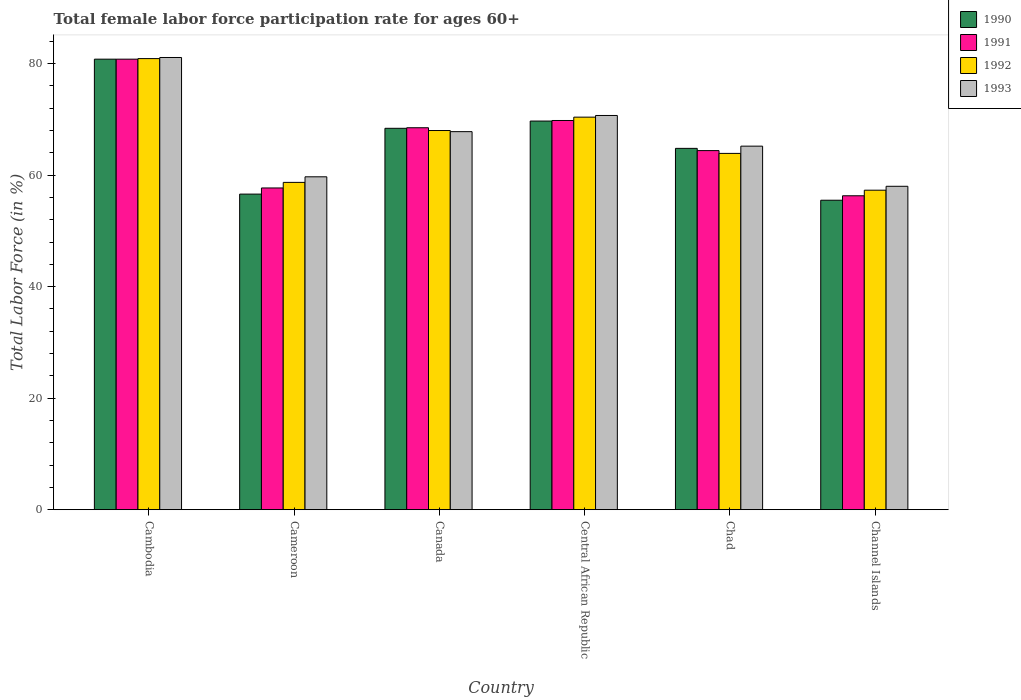How many different coloured bars are there?
Keep it short and to the point. 4. Are the number of bars per tick equal to the number of legend labels?
Keep it short and to the point. Yes. Are the number of bars on each tick of the X-axis equal?
Provide a succinct answer. Yes. How many bars are there on the 5th tick from the right?
Your answer should be compact. 4. In how many cases, is the number of bars for a given country not equal to the number of legend labels?
Give a very brief answer. 0. What is the female labor force participation rate in 1992 in Channel Islands?
Ensure brevity in your answer.  57.3. Across all countries, what is the maximum female labor force participation rate in 1993?
Your response must be concise. 81.1. Across all countries, what is the minimum female labor force participation rate in 1991?
Your answer should be very brief. 56.3. In which country was the female labor force participation rate in 1993 maximum?
Give a very brief answer. Cambodia. In which country was the female labor force participation rate in 1990 minimum?
Your response must be concise. Channel Islands. What is the total female labor force participation rate in 1993 in the graph?
Your answer should be very brief. 402.5. What is the difference between the female labor force participation rate in 1990 in Cambodia and that in Canada?
Provide a short and direct response. 12.4. What is the difference between the female labor force participation rate in 1990 in Channel Islands and the female labor force participation rate in 1992 in Cameroon?
Your response must be concise. -3.2. What is the average female labor force participation rate in 1990 per country?
Your answer should be very brief. 65.97. What is the difference between the female labor force participation rate of/in 1992 and female labor force participation rate of/in 1993 in Chad?
Your answer should be very brief. -1.3. In how many countries, is the female labor force participation rate in 1992 greater than 56 %?
Your response must be concise. 6. What is the ratio of the female labor force participation rate in 1993 in Cambodia to that in Central African Republic?
Keep it short and to the point. 1.15. Is the female labor force participation rate in 1990 in Central African Republic less than that in Chad?
Ensure brevity in your answer.  No. What is the difference between the highest and the second highest female labor force participation rate in 1990?
Make the answer very short. 12.4. What is the difference between the highest and the lowest female labor force participation rate in 1991?
Your response must be concise. 24.5. In how many countries, is the female labor force participation rate in 1990 greater than the average female labor force participation rate in 1990 taken over all countries?
Give a very brief answer. 3. Is the sum of the female labor force participation rate in 1991 in Central African Republic and Channel Islands greater than the maximum female labor force participation rate in 1992 across all countries?
Give a very brief answer. Yes. Is it the case that in every country, the sum of the female labor force participation rate in 1990 and female labor force participation rate in 1992 is greater than the sum of female labor force participation rate in 1993 and female labor force participation rate in 1991?
Ensure brevity in your answer.  No. What does the 3rd bar from the left in Canada represents?
Offer a terse response. 1992. How many bars are there?
Provide a short and direct response. 24. Are all the bars in the graph horizontal?
Your response must be concise. No. What is the difference between two consecutive major ticks on the Y-axis?
Offer a terse response. 20. Does the graph contain any zero values?
Give a very brief answer. No. Where does the legend appear in the graph?
Provide a succinct answer. Top right. What is the title of the graph?
Offer a terse response. Total female labor force participation rate for ages 60+. Does "2003" appear as one of the legend labels in the graph?
Your answer should be very brief. No. What is the label or title of the X-axis?
Keep it short and to the point. Country. What is the Total Labor Force (in %) of 1990 in Cambodia?
Ensure brevity in your answer.  80.8. What is the Total Labor Force (in %) of 1991 in Cambodia?
Keep it short and to the point. 80.8. What is the Total Labor Force (in %) in 1992 in Cambodia?
Make the answer very short. 80.9. What is the Total Labor Force (in %) in 1993 in Cambodia?
Offer a terse response. 81.1. What is the Total Labor Force (in %) in 1990 in Cameroon?
Make the answer very short. 56.6. What is the Total Labor Force (in %) in 1991 in Cameroon?
Offer a terse response. 57.7. What is the Total Labor Force (in %) of 1992 in Cameroon?
Provide a succinct answer. 58.7. What is the Total Labor Force (in %) in 1993 in Cameroon?
Make the answer very short. 59.7. What is the Total Labor Force (in %) in 1990 in Canada?
Your response must be concise. 68.4. What is the Total Labor Force (in %) in 1991 in Canada?
Provide a short and direct response. 68.5. What is the Total Labor Force (in %) of 1992 in Canada?
Keep it short and to the point. 68. What is the Total Labor Force (in %) in 1993 in Canada?
Your answer should be compact. 67.8. What is the Total Labor Force (in %) in 1990 in Central African Republic?
Provide a succinct answer. 69.7. What is the Total Labor Force (in %) in 1991 in Central African Republic?
Give a very brief answer. 69.8. What is the Total Labor Force (in %) of 1992 in Central African Republic?
Provide a short and direct response. 70.4. What is the Total Labor Force (in %) in 1993 in Central African Republic?
Keep it short and to the point. 70.7. What is the Total Labor Force (in %) in 1990 in Chad?
Your answer should be very brief. 64.8. What is the Total Labor Force (in %) of 1991 in Chad?
Provide a succinct answer. 64.4. What is the Total Labor Force (in %) of 1992 in Chad?
Keep it short and to the point. 63.9. What is the Total Labor Force (in %) in 1993 in Chad?
Make the answer very short. 65.2. What is the Total Labor Force (in %) of 1990 in Channel Islands?
Your response must be concise. 55.5. What is the Total Labor Force (in %) of 1991 in Channel Islands?
Offer a terse response. 56.3. What is the Total Labor Force (in %) of 1992 in Channel Islands?
Provide a short and direct response. 57.3. What is the Total Labor Force (in %) in 1993 in Channel Islands?
Give a very brief answer. 58. Across all countries, what is the maximum Total Labor Force (in %) in 1990?
Give a very brief answer. 80.8. Across all countries, what is the maximum Total Labor Force (in %) in 1991?
Offer a very short reply. 80.8. Across all countries, what is the maximum Total Labor Force (in %) of 1992?
Ensure brevity in your answer.  80.9. Across all countries, what is the maximum Total Labor Force (in %) in 1993?
Your answer should be very brief. 81.1. Across all countries, what is the minimum Total Labor Force (in %) in 1990?
Provide a short and direct response. 55.5. Across all countries, what is the minimum Total Labor Force (in %) in 1991?
Make the answer very short. 56.3. Across all countries, what is the minimum Total Labor Force (in %) in 1992?
Your response must be concise. 57.3. Across all countries, what is the minimum Total Labor Force (in %) of 1993?
Your answer should be very brief. 58. What is the total Total Labor Force (in %) of 1990 in the graph?
Offer a terse response. 395.8. What is the total Total Labor Force (in %) in 1991 in the graph?
Provide a short and direct response. 397.5. What is the total Total Labor Force (in %) of 1992 in the graph?
Provide a succinct answer. 399.2. What is the total Total Labor Force (in %) in 1993 in the graph?
Your answer should be compact. 402.5. What is the difference between the Total Labor Force (in %) in 1990 in Cambodia and that in Cameroon?
Offer a very short reply. 24.2. What is the difference between the Total Labor Force (in %) in 1991 in Cambodia and that in Cameroon?
Your response must be concise. 23.1. What is the difference between the Total Labor Force (in %) of 1992 in Cambodia and that in Cameroon?
Your response must be concise. 22.2. What is the difference between the Total Labor Force (in %) in 1993 in Cambodia and that in Cameroon?
Your answer should be very brief. 21.4. What is the difference between the Total Labor Force (in %) in 1990 in Cambodia and that in Canada?
Make the answer very short. 12.4. What is the difference between the Total Labor Force (in %) of 1991 in Cambodia and that in Canada?
Ensure brevity in your answer.  12.3. What is the difference between the Total Labor Force (in %) of 1992 in Cambodia and that in Canada?
Keep it short and to the point. 12.9. What is the difference between the Total Labor Force (in %) of 1990 in Cambodia and that in Central African Republic?
Offer a terse response. 11.1. What is the difference between the Total Labor Force (in %) in 1992 in Cambodia and that in Central African Republic?
Provide a succinct answer. 10.5. What is the difference between the Total Labor Force (in %) in 1990 in Cambodia and that in Chad?
Offer a terse response. 16. What is the difference between the Total Labor Force (in %) in 1991 in Cambodia and that in Chad?
Ensure brevity in your answer.  16.4. What is the difference between the Total Labor Force (in %) in 1993 in Cambodia and that in Chad?
Offer a terse response. 15.9. What is the difference between the Total Labor Force (in %) of 1990 in Cambodia and that in Channel Islands?
Give a very brief answer. 25.3. What is the difference between the Total Labor Force (in %) of 1992 in Cambodia and that in Channel Islands?
Your answer should be very brief. 23.6. What is the difference between the Total Labor Force (in %) of 1993 in Cambodia and that in Channel Islands?
Provide a short and direct response. 23.1. What is the difference between the Total Labor Force (in %) in 1991 in Cameroon and that in Canada?
Offer a terse response. -10.8. What is the difference between the Total Labor Force (in %) in 1992 in Cameroon and that in Canada?
Offer a terse response. -9.3. What is the difference between the Total Labor Force (in %) of 1993 in Cameroon and that in Canada?
Your answer should be very brief. -8.1. What is the difference between the Total Labor Force (in %) of 1990 in Cameroon and that in Central African Republic?
Offer a very short reply. -13.1. What is the difference between the Total Labor Force (in %) in 1992 in Cameroon and that in Central African Republic?
Your response must be concise. -11.7. What is the difference between the Total Labor Force (in %) of 1990 in Cameroon and that in Chad?
Keep it short and to the point. -8.2. What is the difference between the Total Labor Force (in %) of 1993 in Cameroon and that in Chad?
Offer a terse response. -5.5. What is the difference between the Total Labor Force (in %) of 1990 in Cameroon and that in Channel Islands?
Make the answer very short. 1.1. What is the difference between the Total Labor Force (in %) in 1992 in Cameroon and that in Channel Islands?
Keep it short and to the point. 1.4. What is the difference between the Total Labor Force (in %) of 1993 in Cameroon and that in Channel Islands?
Provide a succinct answer. 1.7. What is the difference between the Total Labor Force (in %) of 1990 in Canada and that in Central African Republic?
Give a very brief answer. -1.3. What is the difference between the Total Labor Force (in %) of 1992 in Canada and that in Central African Republic?
Your answer should be compact. -2.4. What is the difference between the Total Labor Force (in %) in 1990 in Canada and that in Chad?
Give a very brief answer. 3.6. What is the difference between the Total Labor Force (in %) in 1992 in Canada and that in Chad?
Offer a very short reply. 4.1. What is the difference between the Total Labor Force (in %) in 1993 in Canada and that in Chad?
Ensure brevity in your answer.  2.6. What is the difference between the Total Labor Force (in %) of 1990 in Central African Republic and that in Chad?
Keep it short and to the point. 4.9. What is the difference between the Total Labor Force (in %) of 1991 in Central African Republic and that in Chad?
Offer a very short reply. 5.4. What is the difference between the Total Labor Force (in %) in 1992 in Central African Republic and that in Chad?
Provide a succinct answer. 6.5. What is the difference between the Total Labor Force (in %) of 1990 in Central African Republic and that in Channel Islands?
Provide a succinct answer. 14.2. What is the difference between the Total Labor Force (in %) of 1991 in Central African Republic and that in Channel Islands?
Provide a short and direct response. 13.5. What is the difference between the Total Labor Force (in %) of 1992 in Central African Republic and that in Channel Islands?
Your answer should be compact. 13.1. What is the difference between the Total Labor Force (in %) in 1993 in Central African Republic and that in Channel Islands?
Keep it short and to the point. 12.7. What is the difference between the Total Labor Force (in %) of 1992 in Chad and that in Channel Islands?
Keep it short and to the point. 6.6. What is the difference between the Total Labor Force (in %) of 1993 in Chad and that in Channel Islands?
Offer a terse response. 7.2. What is the difference between the Total Labor Force (in %) of 1990 in Cambodia and the Total Labor Force (in %) of 1991 in Cameroon?
Offer a very short reply. 23.1. What is the difference between the Total Labor Force (in %) of 1990 in Cambodia and the Total Labor Force (in %) of 1992 in Cameroon?
Give a very brief answer. 22.1. What is the difference between the Total Labor Force (in %) in 1990 in Cambodia and the Total Labor Force (in %) in 1993 in Cameroon?
Keep it short and to the point. 21.1. What is the difference between the Total Labor Force (in %) in 1991 in Cambodia and the Total Labor Force (in %) in 1992 in Cameroon?
Your answer should be very brief. 22.1. What is the difference between the Total Labor Force (in %) in 1991 in Cambodia and the Total Labor Force (in %) in 1993 in Cameroon?
Offer a very short reply. 21.1. What is the difference between the Total Labor Force (in %) in 1992 in Cambodia and the Total Labor Force (in %) in 1993 in Cameroon?
Provide a succinct answer. 21.2. What is the difference between the Total Labor Force (in %) of 1990 in Cambodia and the Total Labor Force (in %) of 1991 in Canada?
Your answer should be compact. 12.3. What is the difference between the Total Labor Force (in %) of 1990 in Cambodia and the Total Labor Force (in %) of 1992 in Canada?
Your response must be concise. 12.8. What is the difference between the Total Labor Force (in %) of 1991 in Cambodia and the Total Labor Force (in %) of 1992 in Canada?
Give a very brief answer. 12.8. What is the difference between the Total Labor Force (in %) of 1991 in Cambodia and the Total Labor Force (in %) of 1993 in Canada?
Provide a succinct answer. 13. What is the difference between the Total Labor Force (in %) of 1990 in Cambodia and the Total Labor Force (in %) of 1991 in Central African Republic?
Give a very brief answer. 11. What is the difference between the Total Labor Force (in %) of 1990 in Cambodia and the Total Labor Force (in %) of 1993 in Central African Republic?
Your answer should be compact. 10.1. What is the difference between the Total Labor Force (in %) of 1991 in Cambodia and the Total Labor Force (in %) of 1993 in Central African Republic?
Make the answer very short. 10.1. What is the difference between the Total Labor Force (in %) of 1990 in Cambodia and the Total Labor Force (in %) of 1991 in Chad?
Offer a terse response. 16.4. What is the difference between the Total Labor Force (in %) in 1990 in Cambodia and the Total Labor Force (in %) in 1992 in Chad?
Offer a terse response. 16.9. What is the difference between the Total Labor Force (in %) in 1990 in Cambodia and the Total Labor Force (in %) in 1991 in Channel Islands?
Ensure brevity in your answer.  24.5. What is the difference between the Total Labor Force (in %) of 1990 in Cambodia and the Total Labor Force (in %) of 1992 in Channel Islands?
Your answer should be compact. 23.5. What is the difference between the Total Labor Force (in %) in 1990 in Cambodia and the Total Labor Force (in %) in 1993 in Channel Islands?
Your answer should be compact. 22.8. What is the difference between the Total Labor Force (in %) in 1991 in Cambodia and the Total Labor Force (in %) in 1992 in Channel Islands?
Offer a terse response. 23.5. What is the difference between the Total Labor Force (in %) of 1991 in Cambodia and the Total Labor Force (in %) of 1993 in Channel Islands?
Offer a very short reply. 22.8. What is the difference between the Total Labor Force (in %) of 1992 in Cambodia and the Total Labor Force (in %) of 1993 in Channel Islands?
Ensure brevity in your answer.  22.9. What is the difference between the Total Labor Force (in %) of 1990 in Cameroon and the Total Labor Force (in %) of 1992 in Canada?
Provide a succinct answer. -11.4. What is the difference between the Total Labor Force (in %) in 1990 in Cameroon and the Total Labor Force (in %) in 1993 in Canada?
Your answer should be very brief. -11.2. What is the difference between the Total Labor Force (in %) of 1992 in Cameroon and the Total Labor Force (in %) of 1993 in Canada?
Provide a short and direct response. -9.1. What is the difference between the Total Labor Force (in %) in 1990 in Cameroon and the Total Labor Force (in %) in 1993 in Central African Republic?
Your answer should be compact. -14.1. What is the difference between the Total Labor Force (in %) of 1991 in Cameroon and the Total Labor Force (in %) of 1992 in Central African Republic?
Provide a short and direct response. -12.7. What is the difference between the Total Labor Force (in %) of 1991 in Cameroon and the Total Labor Force (in %) of 1993 in Central African Republic?
Provide a succinct answer. -13. What is the difference between the Total Labor Force (in %) of 1992 in Cameroon and the Total Labor Force (in %) of 1993 in Central African Republic?
Make the answer very short. -12. What is the difference between the Total Labor Force (in %) of 1990 in Cameroon and the Total Labor Force (in %) of 1991 in Chad?
Keep it short and to the point. -7.8. What is the difference between the Total Labor Force (in %) of 1990 in Cameroon and the Total Labor Force (in %) of 1991 in Channel Islands?
Offer a terse response. 0.3. What is the difference between the Total Labor Force (in %) in 1990 in Cameroon and the Total Labor Force (in %) in 1992 in Channel Islands?
Offer a terse response. -0.7. What is the difference between the Total Labor Force (in %) of 1990 in Cameroon and the Total Labor Force (in %) of 1993 in Channel Islands?
Keep it short and to the point. -1.4. What is the difference between the Total Labor Force (in %) in 1991 in Cameroon and the Total Labor Force (in %) in 1992 in Channel Islands?
Offer a very short reply. 0.4. What is the difference between the Total Labor Force (in %) in 1991 in Cameroon and the Total Labor Force (in %) in 1993 in Channel Islands?
Your answer should be very brief. -0.3. What is the difference between the Total Labor Force (in %) of 1990 in Canada and the Total Labor Force (in %) of 1991 in Central African Republic?
Your answer should be very brief. -1.4. What is the difference between the Total Labor Force (in %) in 1990 in Canada and the Total Labor Force (in %) in 1992 in Central African Republic?
Your answer should be very brief. -2. What is the difference between the Total Labor Force (in %) of 1990 in Canada and the Total Labor Force (in %) of 1993 in Central African Republic?
Your answer should be compact. -2.3. What is the difference between the Total Labor Force (in %) of 1991 in Canada and the Total Labor Force (in %) of 1992 in Central African Republic?
Give a very brief answer. -1.9. What is the difference between the Total Labor Force (in %) of 1991 in Canada and the Total Labor Force (in %) of 1993 in Central African Republic?
Offer a terse response. -2.2. What is the difference between the Total Labor Force (in %) of 1992 in Canada and the Total Labor Force (in %) of 1993 in Central African Republic?
Make the answer very short. -2.7. What is the difference between the Total Labor Force (in %) in 1991 in Canada and the Total Labor Force (in %) in 1992 in Chad?
Give a very brief answer. 4.6. What is the difference between the Total Labor Force (in %) in 1992 in Canada and the Total Labor Force (in %) in 1993 in Chad?
Provide a succinct answer. 2.8. What is the difference between the Total Labor Force (in %) in 1990 in Canada and the Total Labor Force (in %) in 1991 in Channel Islands?
Your response must be concise. 12.1. What is the difference between the Total Labor Force (in %) in 1990 in Canada and the Total Labor Force (in %) in 1993 in Channel Islands?
Offer a terse response. 10.4. What is the difference between the Total Labor Force (in %) in 1991 in Canada and the Total Labor Force (in %) in 1992 in Channel Islands?
Give a very brief answer. 11.2. What is the difference between the Total Labor Force (in %) of 1992 in Canada and the Total Labor Force (in %) of 1993 in Channel Islands?
Provide a succinct answer. 10. What is the difference between the Total Labor Force (in %) of 1990 in Central African Republic and the Total Labor Force (in %) of 1991 in Chad?
Offer a very short reply. 5.3. What is the difference between the Total Labor Force (in %) in 1990 in Central African Republic and the Total Labor Force (in %) in 1992 in Chad?
Ensure brevity in your answer.  5.8. What is the difference between the Total Labor Force (in %) of 1991 in Central African Republic and the Total Labor Force (in %) of 1993 in Chad?
Ensure brevity in your answer.  4.6. What is the difference between the Total Labor Force (in %) of 1990 in Central African Republic and the Total Labor Force (in %) of 1992 in Channel Islands?
Offer a very short reply. 12.4. What is the difference between the Total Labor Force (in %) in 1991 in Central African Republic and the Total Labor Force (in %) in 1993 in Channel Islands?
Offer a very short reply. 11.8. What is the difference between the Total Labor Force (in %) in 1990 in Chad and the Total Labor Force (in %) in 1991 in Channel Islands?
Your response must be concise. 8.5. What is the difference between the Total Labor Force (in %) in 1990 in Chad and the Total Labor Force (in %) in 1992 in Channel Islands?
Make the answer very short. 7.5. What is the difference between the Total Labor Force (in %) of 1990 in Chad and the Total Labor Force (in %) of 1993 in Channel Islands?
Offer a very short reply. 6.8. What is the difference between the Total Labor Force (in %) in 1991 in Chad and the Total Labor Force (in %) in 1993 in Channel Islands?
Give a very brief answer. 6.4. What is the difference between the Total Labor Force (in %) of 1992 in Chad and the Total Labor Force (in %) of 1993 in Channel Islands?
Offer a very short reply. 5.9. What is the average Total Labor Force (in %) of 1990 per country?
Your response must be concise. 65.97. What is the average Total Labor Force (in %) in 1991 per country?
Your answer should be compact. 66.25. What is the average Total Labor Force (in %) of 1992 per country?
Offer a very short reply. 66.53. What is the average Total Labor Force (in %) of 1993 per country?
Offer a very short reply. 67.08. What is the difference between the Total Labor Force (in %) in 1990 and Total Labor Force (in %) in 1992 in Cambodia?
Make the answer very short. -0.1. What is the difference between the Total Labor Force (in %) in 1991 and Total Labor Force (in %) in 1993 in Cambodia?
Offer a very short reply. -0.3. What is the difference between the Total Labor Force (in %) of 1990 and Total Labor Force (in %) of 1993 in Cameroon?
Keep it short and to the point. -3.1. What is the difference between the Total Labor Force (in %) in 1992 and Total Labor Force (in %) in 1993 in Cameroon?
Give a very brief answer. -1. What is the difference between the Total Labor Force (in %) in 1990 and Total Labor Force (in %) in 1991 in Canada?
Keep it short and to the point. -0.1. What is the difference between the Total Labor Force (in %) in 1990 and Total Labor Force (in %) in 1991 in Central African Republic?
Provide a succinct answer. -0.1. What is the difference between the Total Labor Force (in %) in 1990 and Total Labor Force (in %) in 1993 in Central African Republic?
Give a very brief answer. -1. What is the difference between the Total Labor Force (in %) of 1990 and Total Labor Force (in %) of 1991 in Chad?
Your answer should be very brief. 0.4. What is the difference between the Total Labor Force (in %) in 1990 and Total Labor Force (in %) in 1992 in Chad?
Keep it short and to the point. 0.9. What is the difference between the Total Labor Force (in %) of 1990 and Total Labor Force (in %) of 1993 in Chad?
Give a very brief answer. -0.4. What is the difference between the Total Labor Force (in %) in 1990 and Total Labor Force (in %) in 1991 in Channel Islands?
Give a very brief answer. -0.8. What is the difference between the Total Labor Force (in %) of 1991 and Total Labor Force (in %) of 1992 in Channel Islands?
Offer a terse response. -1. What is the difference between the Total Labor Force (in %) in 1991 and Total Labor Force (in %) in 1993 in Channel Islands?
Offer a very short reply. -1.7. What is the difference between the Total Labor Force (in %) in 1992 and Total Labor Force (in %) in 1993 in Channel Islands?
Provide a short and direct response. -0.7. What is the ratio of the Total Labor Force (in %) in 1990 in Cambodia to that in Cameroon?
Give a very brief answer. 1.43. What is the ratio of the Total Labor Force (in %) in 1991 in Cambodia to that in Cameroon?
Your answer should be compact. 1.4. What is the ratio of the Total Labor Force (in %) in 1992 in Cambodia to that in Cameroon?
Give a very brief answer. 1.38. What is the ratio of the Total Labor Force (in %) in 1993 in Cambodia to that in Cameroon?
Provide a succinct answer. 1.36. What is the ratio of the Total Labor Force (in %) of 1990 in Cambodia to that in Canada?
Make the answer very short. 1.18. What is the ratio of the Total Labor Force (in %) of 1991 in Cambodia to that in Canada?
Keep it short and to the point. 1.18. What is the ratio of the Total Labor Force (in %) of 1992 in Cambodia to that in Canada?
Offer a very short reply. 1.19. What is the ratio of the Total Labor Force (in %) of 1993 in Cambodia to that in Canada?
Make the answer very short. 1.2. What is the ratio of the Total Labor Force (in %) of 1990 in Cambodia to that in Central African Republic?
Keep it short and to the point. 1.16. What is the ratio of the Total Labor Force (in %) of 1991 in Cambodia to that in Central African Republic?
Offer a very short reply. 1.16. What is the ratio of the Total Labor Force (in %) of 1992 in Cambodia to that in Central African Republic?
Offer a terse response. 1.15. What is the ratio of the Total Labor Force (in %) of 1993 in Cambodia to that in Central African Republic?
Your answer should be compact. 1.15. What is the ratio of the Total Labor Force (in %) of 1990 in Cambodia to that in Chad?
Offer a terse response. 1.25. What is the ratio of the Total Labor Force (in %) in 1991 in Cambodia to that in Chad?
Give a very brief answer. 1.25. What is the ratio of the Total Labor Force (in %) of 1992 in Cambodia to that in Chad?
Your response must be concise. 1.27. What is the ratio of the Total Labor Force (in %) in 1993 in Cambodia to that in Chad?
Your response must be concise. 1.24. What is the ratio of the Total Labor Force (in %) of 1990 in Cambodia to that in Channel Islands?
Ensure brevity in your answer.  1.46. What is the ratio of the Total Labor Force (in %) in 1991 in Cambodia to that in Channel Islands?
Provide a short and direct response. 1.44. What is the ratio of the Total Labor Force (in %) of 1992 in Cambodia to that in Channel Islands?
Your response must be concise. 1.41. What is the ratio of the Total Labor Force (in %) in 1993 in Cambodia to that in Channel Islands?
Provide a succinct answer. 1.4. What is the ratio of the Total Labor Force (in %) in 1990 in Cameroon to that in Canada?
Make the answer very short. 0.83. What is the ratio of the Total Labor Force (in %) of 1991 in Cameroon to that in Canada?
Your answer should be very brief. 0.84. What is the ratio of the Total Labor Force (in %) of 1992 in Cameroon to that in Canada?
Make the answer very short. 0.86. What is the ratio of the Total Labor Force (in %) in 1993 in Cameroon to that in Canada?
Keep it short and to the point. 0.88. What is the ratio of the Total Labor Force (in %) of 1990 in Cameroon to that in Central African Republic?
Your response must be concise. 0.81. What is the ratio of the Total Labor Force (in %) of 1991 in Cameroon to that in Central African Republic?
Your answer should be very brief. 0.83. What is the ratio of the Total Labor Force (in %) of 1992 in Cameroon to that in Central African Republic?
Your response must be concise. 0.83. What is the ratio of the Total Labor Force (in %) of 1993 in Cameroon to that in Central African Republic?
Offer a terse response. 0.84. What is the ratio of the Total Labor Force (in %) of 1990 in Cameroon to that in Chad?
Provide a short and direct response. 0.87. What is the ratio of the Total Labor Force (in %) of 1991 in Cameroon to that in Chad?
Your answer should be very brief. 0.9. What is the ratio of the Total Labor Force (in %) in 1992 in Cameroon to that in Chad?
Keep it short and to the point. 0.92. What is the ratio of the Total Labor Force (in %) in 1993 in Cameroon to that in Chad?
Offer a very short reply. 0.92. What is the ratio of the Total Labor Force (in %) of 1990 in Cameroon to that in Channel Islands?
Your answer should be very brief. 1.02. What is the ratio of the Total Labor Force (in %) in 1991 in Cameroon to that in Channel Islands?
Offer a very short reply. 1.02. What is the ratio of the Total Labor Force (in %) in 1992 in Cameroon to that in Channel Islands?
Ensure brevity in your answer.  1.02. What is the ratio of the Total Labor Force (in %) in 1993 in Cameroon to that in Channel Islands?
Give a very brief answer. 1.03. What is the ratio of the Total Labor Force (in %) of 1990 in Canada to that in Central African Republic?
Your answer should be very brief. 0.98. What is the ratio of the Total Labor Force (in %) in 1991 in Canada to that in Central African Republic?
Ensure brevity in your answer.  0.98. What is the ratio of the Total Labor Force (in %) of 1992 in Canada to that in Central African Republic?
Offer a terse response. 0.97. What is the ratio of the Total Labor Force (in %) in 1990 in Canada to that in Chad?
Your answer should be very brief. 1.06. What is the ratio of the Total Labor Force (in %) in 1991 in Canada to that in Chad?
Your answer should be compact. 1.06. What is the ratio of the Total Labor Force (in %) of 1992 in Canada to that in Chad?
Your answer should be compact. 1.06. What is the ratio of the Total Labor Force (in %) in 1993 in Canada to that in Chad?
Your answer should be compact. 1.04. What is the ratio of the Total Labor Force (in %) in 1990 in Canada to that in Channel Islands?
Ensure brevity in your answer.  1.23. What is the ratio of the Total Labor Force (in %) in 1991 in Canada to that in Channel Islands?
Keep it short and to the point. 1.22. What is the ratio of the Total Labor Force (in %) of 1992 in Canada to that in Channel Islands?
Keep it short and to the point. 1.19. What is the ratio of the Total Labor Force (in %) in 1993 in Canada to that in Channel Islands?
Provide a succinct answer. 1.17. What is the ratio of the Total Labor Force (in %) of 1990 in Central African Republic to that in Chad?
Offer a very short reply. 1.08. What is the ratio of the Total Labor Force (in %) of 1991 in Central African Republic to that in Chad?
Provide a short and direct response. 1.08. What is the ratio of the Total Labor Force (in %) of 1992 in Central African Republic to that in Chad?
Ensure brevity in your answer.  1.1. What is the ratio of the Total Labor Force (in %) in 1993 in Central African Republic to that in Chad?
Your answer should be very brief. 1.08. What is the ratio of the Total Labor Force (in %) in 1990 in Central African Republic to that in Channel Islands?
Your answer should be very brief. 1.26. What is the ratio of the Total Labor Force (in %) in 1991 in Central African Republic to that in Channel Islands?
Your response must be concise. 1.24. What is the ratio of the Total Labor Force (in %) of 1992 in Central African Republic to that in Channel Islands?
Your answer should be compact. 1.23. What is the ratio of the Total Labor Force (in %) in 1993 in Central African Republic to that in Channel Islands?
Your answer should be compact. 1.22. What is the ratio of the Total Labor Force (in %) in 1990 in Chad to that in Channel Islands?
Make the answer very short. 1.17. What is the ratio of the Total Labor Force (in %) of 1991 in Chad to that in Channel Islands?
Keep it short and to the point. 1.14. What is the ratio of the Total Labor Force (in %) in 1992 in Chad to that in Channel Islands?
Provide a short and direct response. 1.12. What is the ratio of the Total Labor Force (in %) of 1993 in Chad to that in Channel Islands?
Ensure brevity in your answer.  1.12. What is the difference between the highest and the second highest Total Labor Force (in %) of 1993?
Your answer should be compact. 10.4. What is the difference between the highest and the lowest Total Labor Force (in %) of 1990?
Offer a very short reply. 25.3. What is the difference between the highest and the lowest Total Labor Force (in %) in 1992?
Ensure brevity in your answer.  23.6. What is the difference between the highest and the lowest Total Labor Force (in %) in 1993?
Offer a terse response. 23.1. 